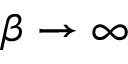Convert formula to latex. <formula><loc_0><loc_0><loc_500><loc_500>\beta \rightarrow \infty</formula> 